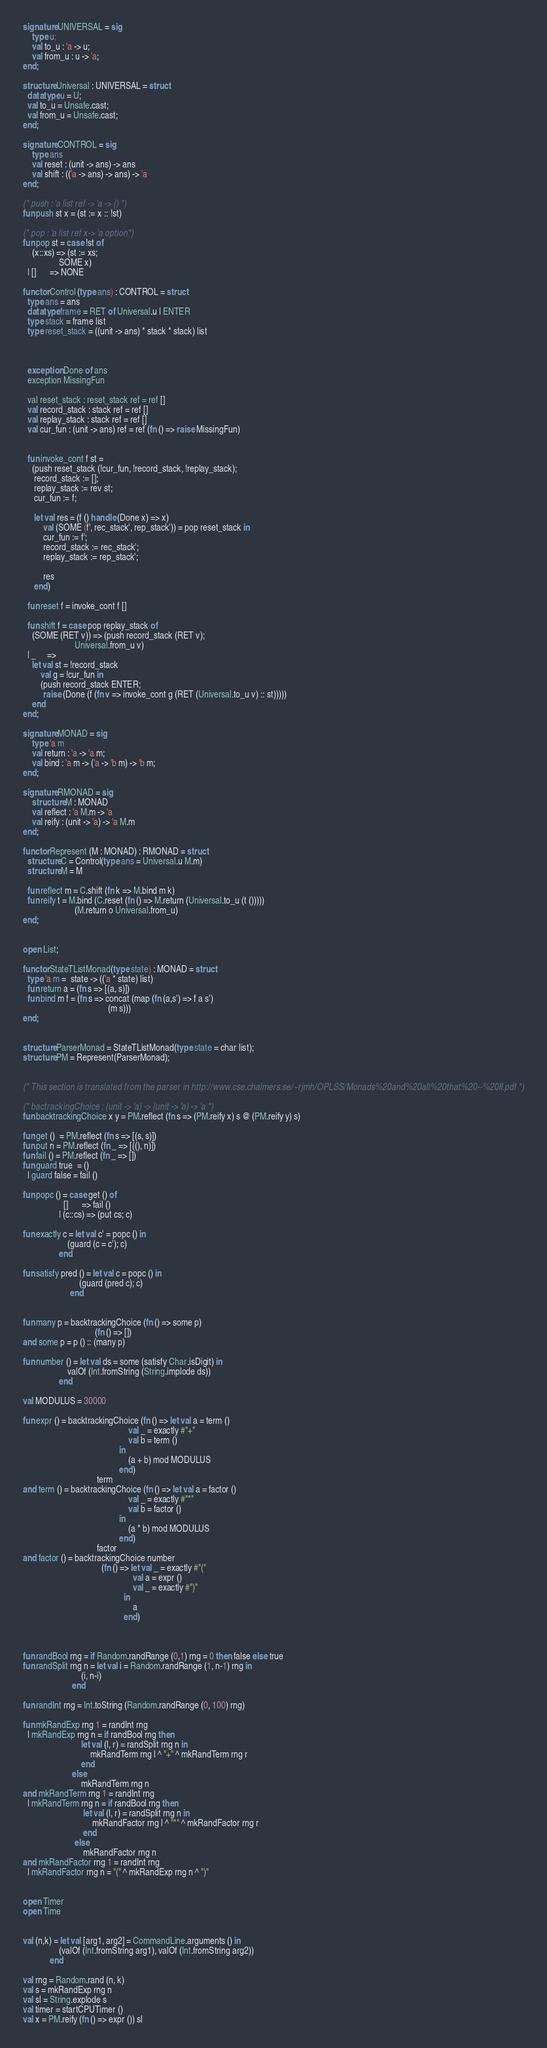<code> <loc_0><loc_0><loc_500><loc_500><_SML_>signature UNIVERSAL = sig
    type u;
    val to_u : 'a -> u;
    val from_u : u -> 'a;
end;

structure Universal : UNIVERSAL = struct
  datatype u = U;
  val to_u = Unsafe.cast;
  val from_u = Unsafe.cast;
end;

signature CONTROL = sig
    type ans
    val reset : (unit -> ans) -> ans
    val shift : (('a -> ans) -> ans) -> 'a
end;

(* push : 'a list ref -> 'a -> () *)
fun push st x = (st := x :: !st)

(* pop : 'a list ref x-> 'a option*)
fun pop st = case !st of
    (x::xs) => (st := xs;
                SOME x)
  | []      => NONE

functor Control (type ans) : CONTROL = struct
  type ans = ans
  datatype frame = RET of Universal.u | ENTER
  type stack = frame list
  type reset_stack = ((unit -> ans) * stack * stack) list


                                                     
  exception Done of ans
  exception MissingFun

  val reset_stack : reset_stack ref = ref []
  val record_stack : stack ref = ref []
  val replay_stack : stack ref = ref []
  val cur_fun : (unit -> ans) ref = ref (fn () => raise MissingFun)


  fun invoke_cont f st =
    (push reset_stack (!cur_fun, !record_stack, !replay_stack);
     record_stack := [];
     replay_stack := rev st;
     cur_fun := f;
     
     let val res = (f () handle (Done x) => x)
         val (SOME (f', rec_stack', rep_stack')) = pop reset_stack in
         cur_fun := f';
         record_stack := rec_stack';
         replay_stack := rep_stack';
         
         res
     end)

  fun reset f = invoke_cont f []

  fun shift f = case pop replay_stack of
    (SOME (RET v)) => (push record_stack (RET v);
                       Universal.from_u v)
  | _     =>
    let val st = !record_stack
        val g = !cur_fun in
        (push record_stack ENTER;
         raise (Done (f (fn v => invoke_cont g (RET (Universal.to_u v) :: st)))))
    end
end;

signature MONAD = sig
    type 'a m
    val return : 'a -> 'a m;
    val bind : 'a m -> ('a -> 'b m) -> 'b m;
end;

signature RMONAD = sig
    structure M : MONAD
    val reflect : 'a M.m -> 'a
    val reify : (unit -> 'a) -> 'a M.m
end;

functor Represent (M : MONAD) : RMONAD = struct
  structure C = Control(type ans = Universal.u M.m)
  structure M = M
                    
  fun reflect m = C.shift (fn k => M.bind m k)
  fun reify t = M.bind (C.reset (fn () => M.return (Universal.to_u (t ()))))
                       (M.return o Universal.from_u)
end;


open List;

functor StateTListMonad(type state) : MONAD = struct
  type 'a m =  state -> (('a * state) list)
  fun return a = (fn s => [(a, s)])
  fun bind m f = (fn s => concat (map (fn (a,s') => f a s')
                                      (m s)))
end;


structure ParserMonad = StateTListMonad(type state = char list);
structure PM = Represent(ParserMonad);


(* This section is translated from the parser in http://www.cse.chalmers.se/~rjmh/OPLSS/Monads%20and%20all%20that%20--%20II.pdf *)

(* bactrackingChoice : (unit -> 'a) -> (unit -> 'a) -> 'a *)
fun backtrackingChoice x y = PM.reflect (fn s => (PM.reify x) s @ (PM.reify y) s)
                                                              
fun get ()  = PM.reflect (fn s => [(s, s)])
fun put n = PM.reflect (fn _ => [((), n)])
fun fail () = PM.reflect (fn _ => [])
fun guard true  = ()
  | guard false = fail ()

fun popc () = case get () of
                  []      => fail ()
                | (c::cs) => (put cs; c)
                      
fun exactly c = let val c' = popc () in
                    (guard (c = c'); c)
                end

fun satisfy pred () = let val c = popc () in
                         (guard (pred c); c)
                     end

                       
fun many p = backtrackingChoice (fn () => some p)
                                (fn () => [])
and some p = p () :: (many p)
                         
fun number () = let val ds = some (satisfy Char.isDigit) in
                    valOf (Int.fromString (String.implode ds))
                end

val MODULUS = 30000

fun expr () = backtrackingChoice (fn () => let val a = term ()
                                               val _ = exactly #"+"
                                               val b = term ()
                                           in
                                               (a + b) mod MODULUS
                                           end)
                                 term
and term () = backtrackingChoice (fn () => let val a = factor ()
                                               val _ = exactly #"*"
                                               val b = factor ()
                                           in
                                               (a * b) mod MODULUS
                                           end)
                                 factor
and factor () = backtrackingChoice number
                                   (fn () => let val _ = exactly #"("
                                                 val a = expr ()
                                                 val _ = exactly #")"
                                             in
                                                 a
                                             end)
                             

                 
fun randBool rng = if Random.randRange (0,1) rng = 0 then false else true
fun randSplit rng n = let val i = Random.randRange (1, n-1) rng in
                          (i, n-i)
                      end

fun randInt rng = Int.toString (Random.randRange (0, 100) rng)
                          
fun mkRandExp rng 1 = randInt rng
  | mkRandExp rng n = if randBool rng then
                          let val (l, r) = randSplit rng n in
                              mkRandTerm rng l ^ "+" ^ mkRandTerm rng r
                          end
                      else
                          mkRandTerm rng n
and mkRandTerm rng 1 = randInt rng
  | mkRandTerm rng n = if randBool rng then
                           let val (l, r) = randSplit rng n in
                               mkRandFactor rng l ^ "*" ^ mkRandFactor rng r
                           end
                       else
                           mkRandFactor rng n
and mkRandFactor rng 1 = randInt rng
  | mkRandFactor rng n = "(" ^ mkRandExp rng n ^ ")"

                                                     
open Timer
open Time


val (n,k) = let val [arg1, arg2] = CommandLine.arguments () in
                (valOf (Int.fromString arg1), valOf (Int.fromString arg2))
            end

val rng = Random.rand (n, k)
val s = mkRandExp rng n
val sl = String.explode s
val timer = startCPUTimer ()
val x = PM.reify (fn () => expr ()) sl</code> 